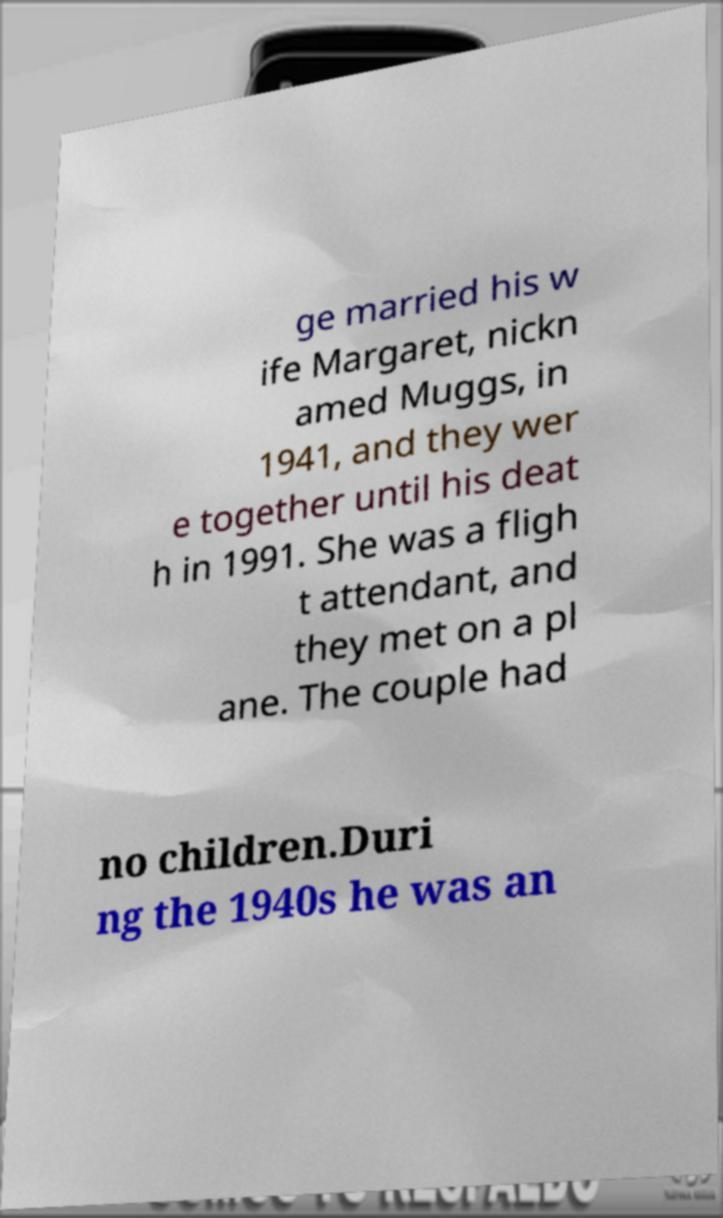Please identify and transcribe the text found in this image. ge married his w ife Margaret, nickn amed Muggs, in 1941, and they wer e together until his deat h in 1991. She was a fligh t attendant, and they met on a pl ane. The couple had no children.Duri ng the 1940s he was an 